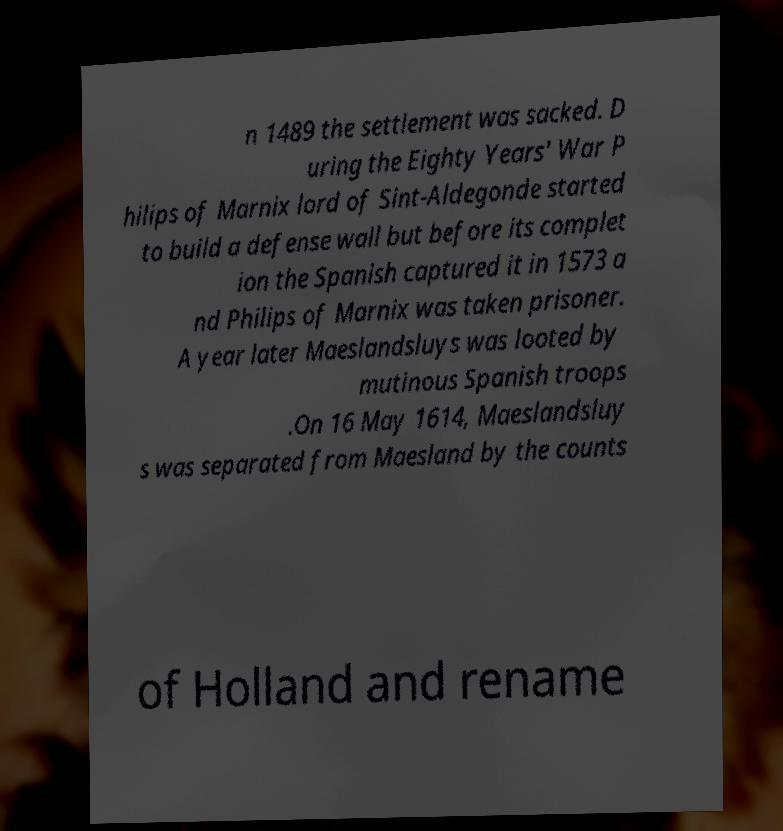Please read and relay the text visible in this image. What does it say? n 1489 the settlement was sacked. D uring the Eighty Years' War P hilips of Marnix lord of Sint-Aldegonde started to build a defense wall but before its complet ion the Spanish captured it in 1573 a nd Philips of Marnix was taken prisoner. A year later Maeslandsluys was looted by mutinous Spanish troops .On 16 May 1614, Maeslandsluy s was separated from Maesland by the counts of Holland and rename 